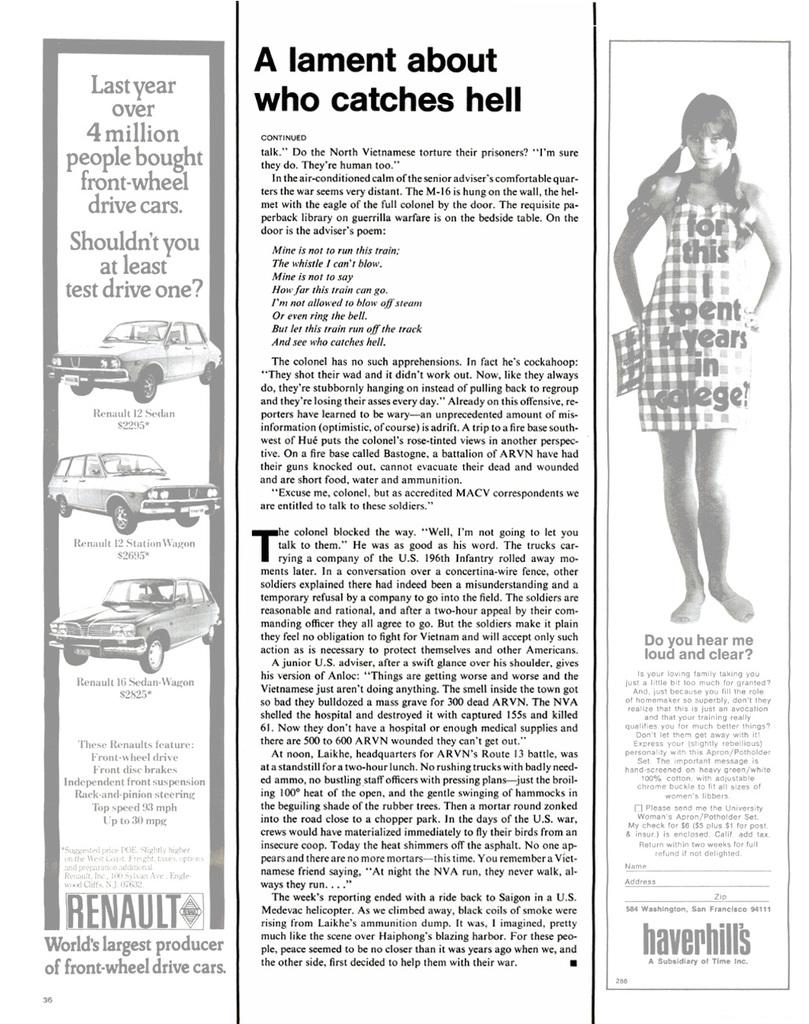What is the main subject of the image? There is a picture of a woman in the image. What else can be seen in the image besides the woman? There are cars in the image. Is there any text present in the image? Yes, there is text present in the image. What type of linen is draped over the woman in the image? There is no linen present in the image; it only features a picture of a woman, cars, and text. 